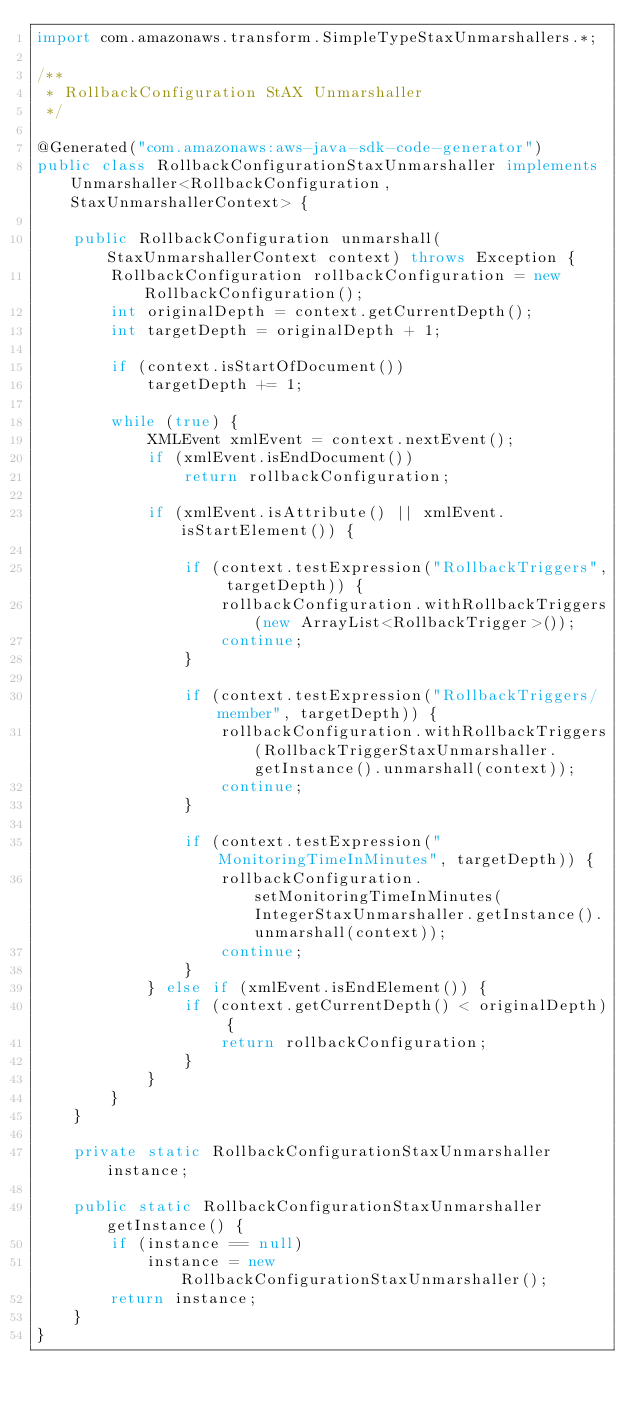Convert code to text. <code><loc_0><loc_0><loc_500><loc_500><_Java_>import com.amazonaws.transform.SimpleTypeStaxUnmarshallers.*;

/**
 * RollbackConfiguration StAX Unmarshaller
 */

@Generated("com.amazonaws:aws-java-sdk-code-generator")
public class RollbackConfigurationStaxUnmarshaller implements Unmarshaller<RollbackConfiguration, StaxUnmarshallerContext> {

    public RollbackConfiguration unmarshall(StaxUnmarshallerContext context) throws Exception {
        RollbackConfiguration rollbackConfiguration = new RollbackConfiguration();
        int originalDepth = context.getCurrentDepth();
        int targetDepth = originalDepth + 1;

        if (context.isStartOfDocument())
            targetDepth += 1;

        while (true) {
            XMLEvent xmlEvent = context.nextEvent();
            if (xmlEvent.isEndDocument())
                return rollbackConfiguration;

            if (xmlEvent.isAttribute() || xmlEvent.isStartElement()) {

                if (context.testExpression("RollbackTriggers", targetDepth)) {
                    rollbackConfiguration.withRollbackTriggers(new ArrayList<RollbackTrigger>());
                    continue;
                }

                if (context.testExpression("RollbackTriggers/member", targetDepth)) {
                    rollbackConfiguration.withRollbackTriggers(RollbackTriggerStaxUnmarshaller.getInstance().unmarshall(context));
                    continue;
                }

                if (context.testExpression("MonitoringTimeInMinutes", targetDepth)) {
                    rollbackConfiguration.setMonitoringTimeInMinutes(IntegerStaxUnmarshaller.getInstance().unmarshall(context));
                    continue;
                }
            } else if (xmlEvent.isEndElement()) {
                if (context.getCurrentDepth() < originalDepth) {
                    return rollbackConfiguration;
                }
            }
        }
    }

    private static RollbackConfigurationStaxUnmarshaller instance;

    public static RollbackConfigurationStaxUnmarshaller getInstance() {
        if (instance == null)
            instance = new RollbackConfigurationStaxUnmarshaller();
        return instance;
    }
}
</code> 